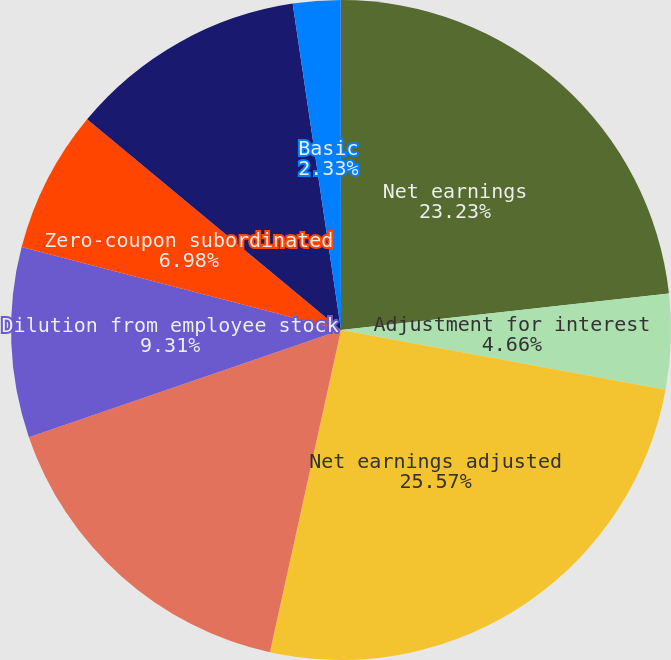Convert chart. <chart><loc_0><loc_0><loc_500><loc_500><pie_chart><fcel>Net earnings<fcel>Adjustment for interest<fcel>Net earnings adjusted<fcel>Weighted-average shares used<fcel>Dilution from employee stock<fcel>Zero-coupon subordinated<fcel>Dilutive potential common<fcel>Basic<fcel>Diluted<nl><fcel>23.23%<fcel>4.66%<fcel>25.56%<fcel>16.28%<fcel>9.31%<fcel>6.98%<fcel>11.63%<fcel>2.33%<fcel>0.01%<nl></chart> 